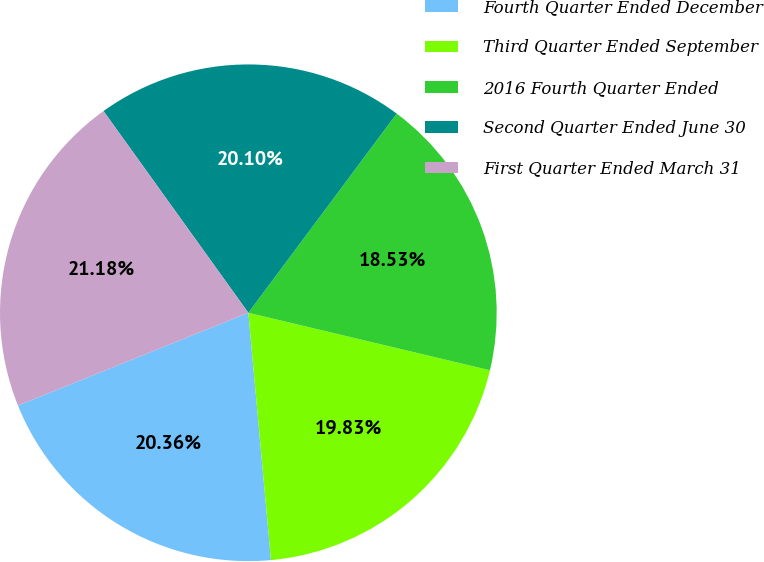Convert chart to OTSL. <chart><loc_0><loc_0><loc_500><loc_500><pie_chart><fcel>Fourth Quarter Ended December<fcel>Third Quarter Ended September<fcel>2016 Fourth Quarter Ended<fcel>Second Quarter Ended June 30<fcel>First Quarter Ended March 31<nl><fcel>20.36%<fcel>19.83%<fcel>18.53%<fcel>20.1%<fcel>21.18%<nl></chart> 